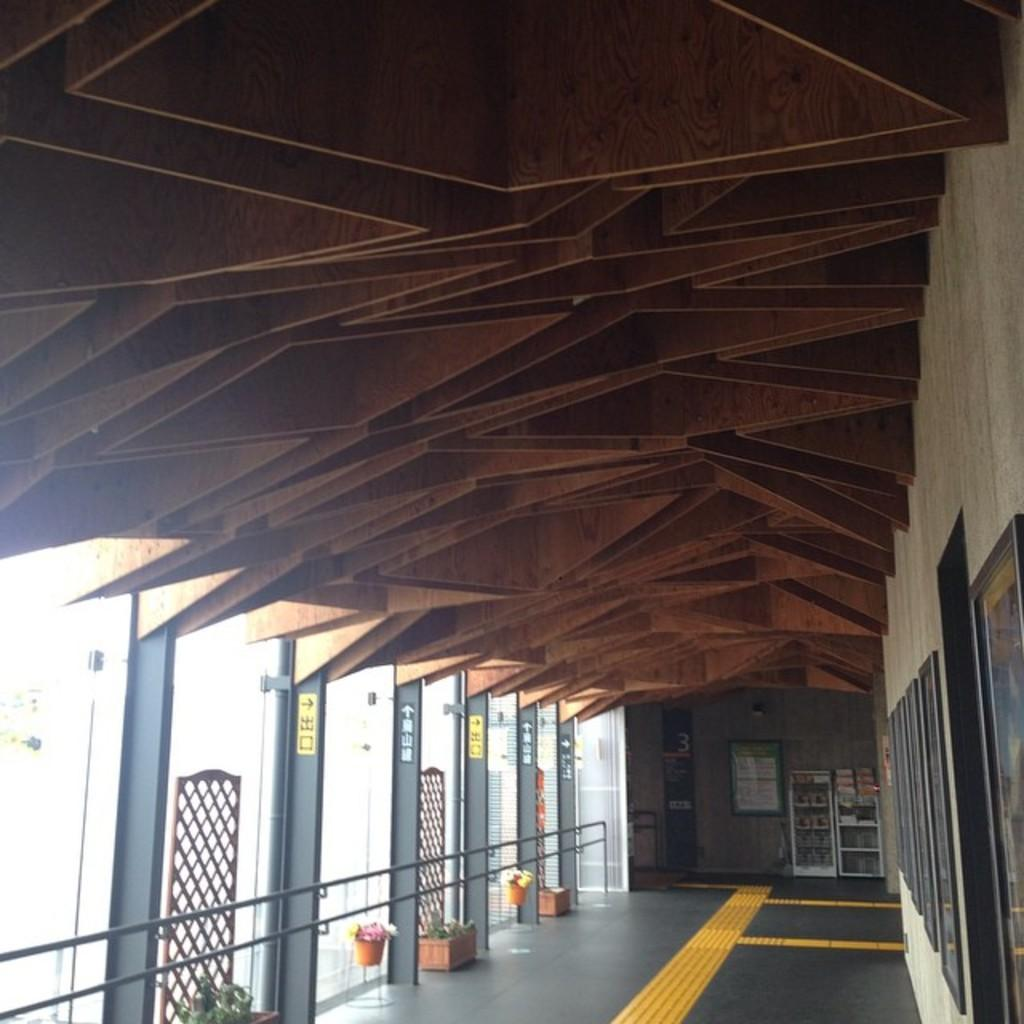What is the surface visible in the image? There is a floor visible in the image. What type of vegetation can be seen in the image? There are plants in pots in the image. What else is visible in the image besides the floor and plants? There are objects visible in the image. What can be seen on the wall in the image? There is a wall with frames in the image. What architectural features are present in the image? There are pillars in the image. How many ducks are sitting on the pillars in the image? There are no ducks present in the image; it only features plants in pots, objects, a wall with frames, and pillars. 